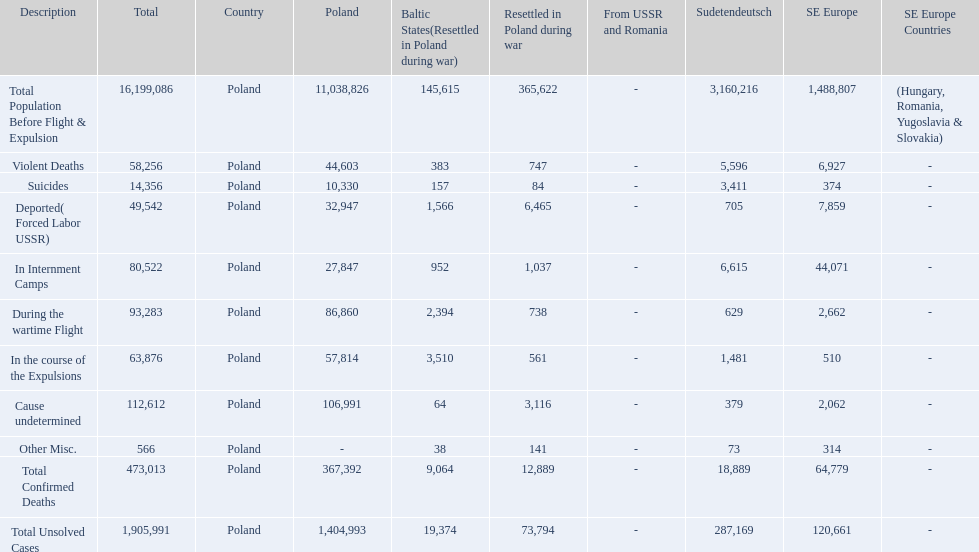What were all of the types of deaths? Violent Deaths, Suicides, Deported( Forced Labor USSR), In Internment Camps, During the wartime Flight, In the course of the Expulsions, Cause undetermined, Other Misc. And their totals in the baltic states? 383, 157, 1,566, 952, 2,394, 3,510, 64, 38. Were more deaths in the baltic states caused by undetermined causes or misc.? Cause undetermined. 